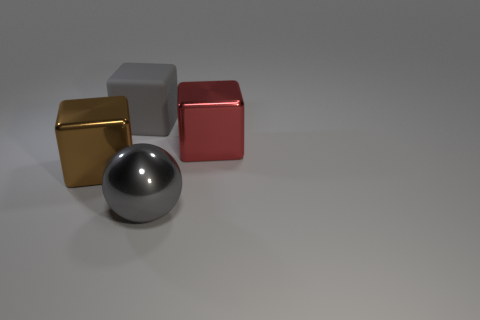There is a block that is to the right of the gray block; is its size the same as the large gray rubber thing?
Offer a terse response. Yes. The object to the left of the gray rubber object is what color?
Keep it short and to the point. Brown. What is the color of the other metallic thing that is the same shape as the large red thing?
Keep it short and to the point. Brown. How many big gray objects are behind the shiny block left of the large block on the right side of the large metallic sphere?
Your response must be concise. 1. Are there any other things that have the same material as the large red cube?
Provide a succinct answer. Yes. Is the number of red metal things that are in front of the brown shiny object less than the number of big shiny objects?
Offer a very short reply. Yes. Does the rubber block have the same color as the big sphere?
Your answer should be compact. Yes. The gray object that is the same shape as the red metal object is what size?
Give a very brief answer. Large. What number of large red blocks are made of the same material as the gray cube?
Offer a terse response. 0. Are the thing left of the gray matte cube and the ball made of the same material?
Ensure brevity in your answer.  Yes. 